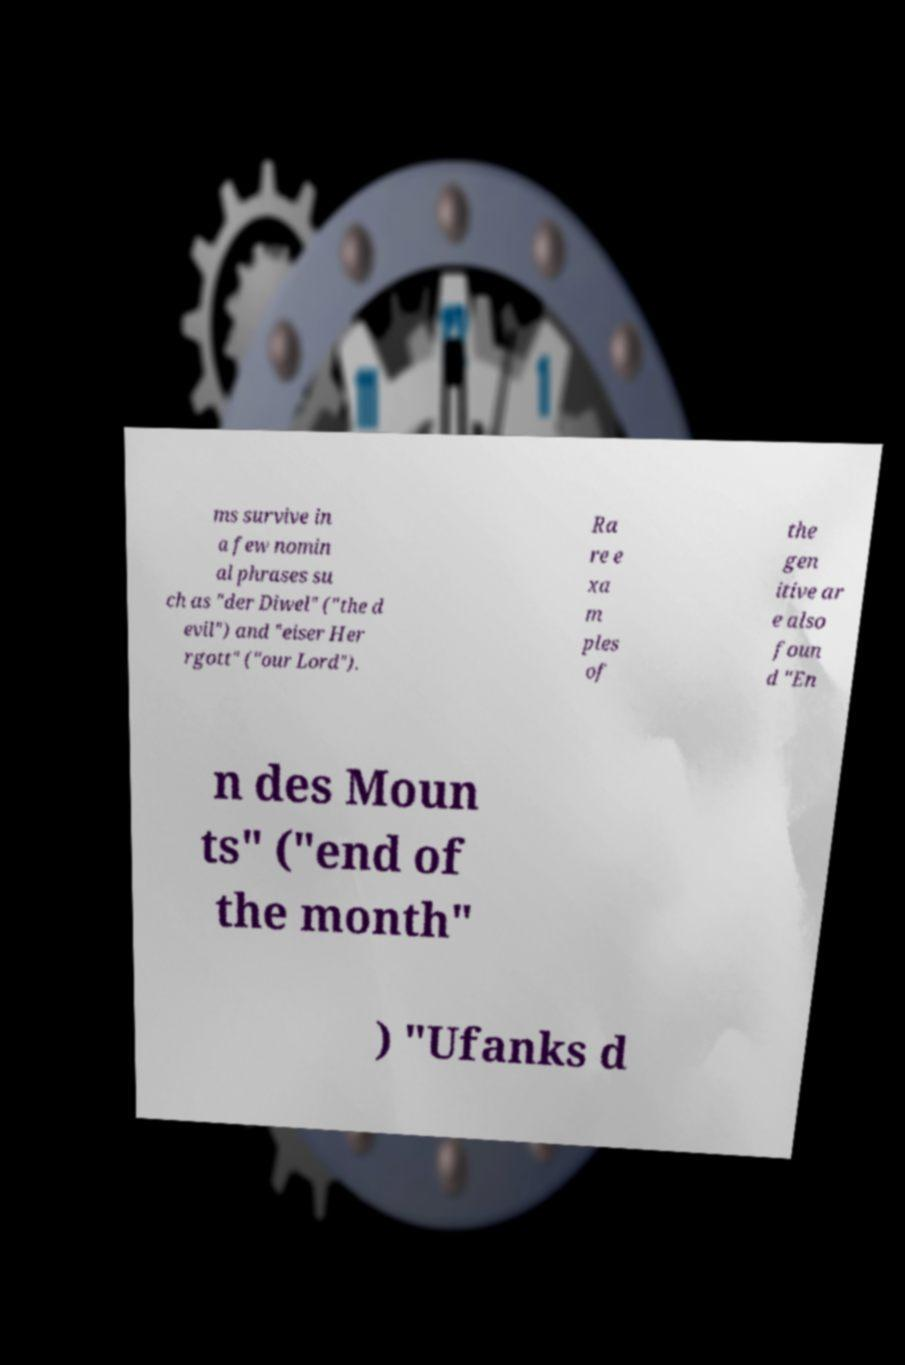Can you read and provide the text displayed in the image?This photo seems to have some interesting text. Can you extract and type it out for me? ms survive in a few nomin al phrases su ch as "der Diwel" ("the d evil") and "eiser Her rgott" ("our Lord"). Ra re e xa m ples of the gen itive ar e also foun d "En n des Moun ts" ("end of the month" ) "Ufanks d 